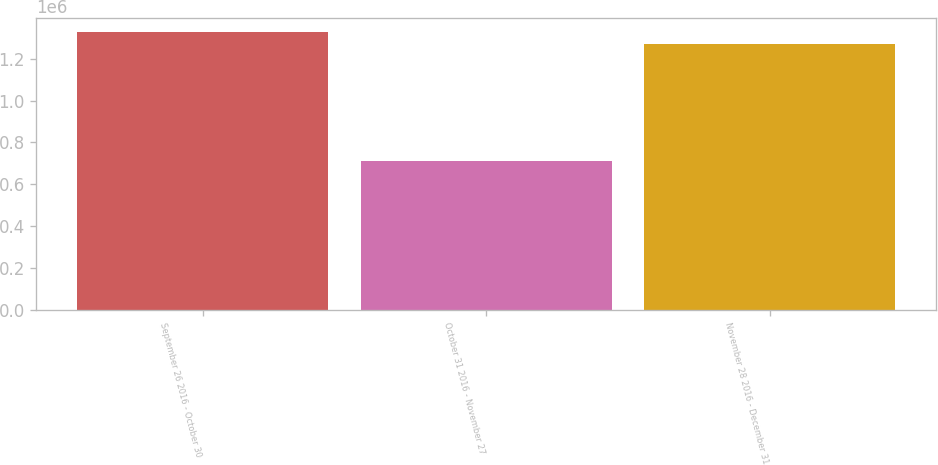<chart> <loc_0><loc_0><loc_500><loc_500><bar_chart><fcel>September 26 2016 - October 30<fcel>October 31 2016 - November 27<fcel>November 28 2016 - December 31<nl><fcel>1.32884e+06<fcel>711974<fcel>1.27067e+06<nl></chart> 